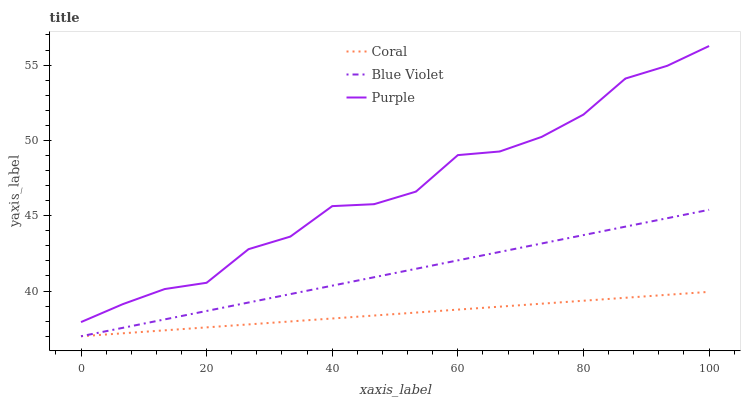Does Coral have the minimum area under the curve?
Answer yes or no. Yes. Does Purple have the maximum area under the curve?
Answer yes or no. Yes. Does Blue Violet have the minimum area under the curve?
Answer yes or no. No. Does Blue Violet have the maximum area under the curve?
Answer yes or no. No. Is Blue Violet the smoothest?
Answer yes or no. Yes. Is Purple the roughest?
Answer yes or no. Yes. Is Coral the smoothest?
Answer yes or no. No. Is Coral the roughest?
Answer yes or no. No. Does Purple have the highest value?
Answer yes or no. Yes. Does Blue Violet have the highest value?
Answer yes or no. No. Is Coral less than Purple?
Answer yes or no. Yes. Is Purple greater than Blue Violet?
Answer yes or no. Yes. Does Coral intersect Purple?
Answer yes or no. No. 